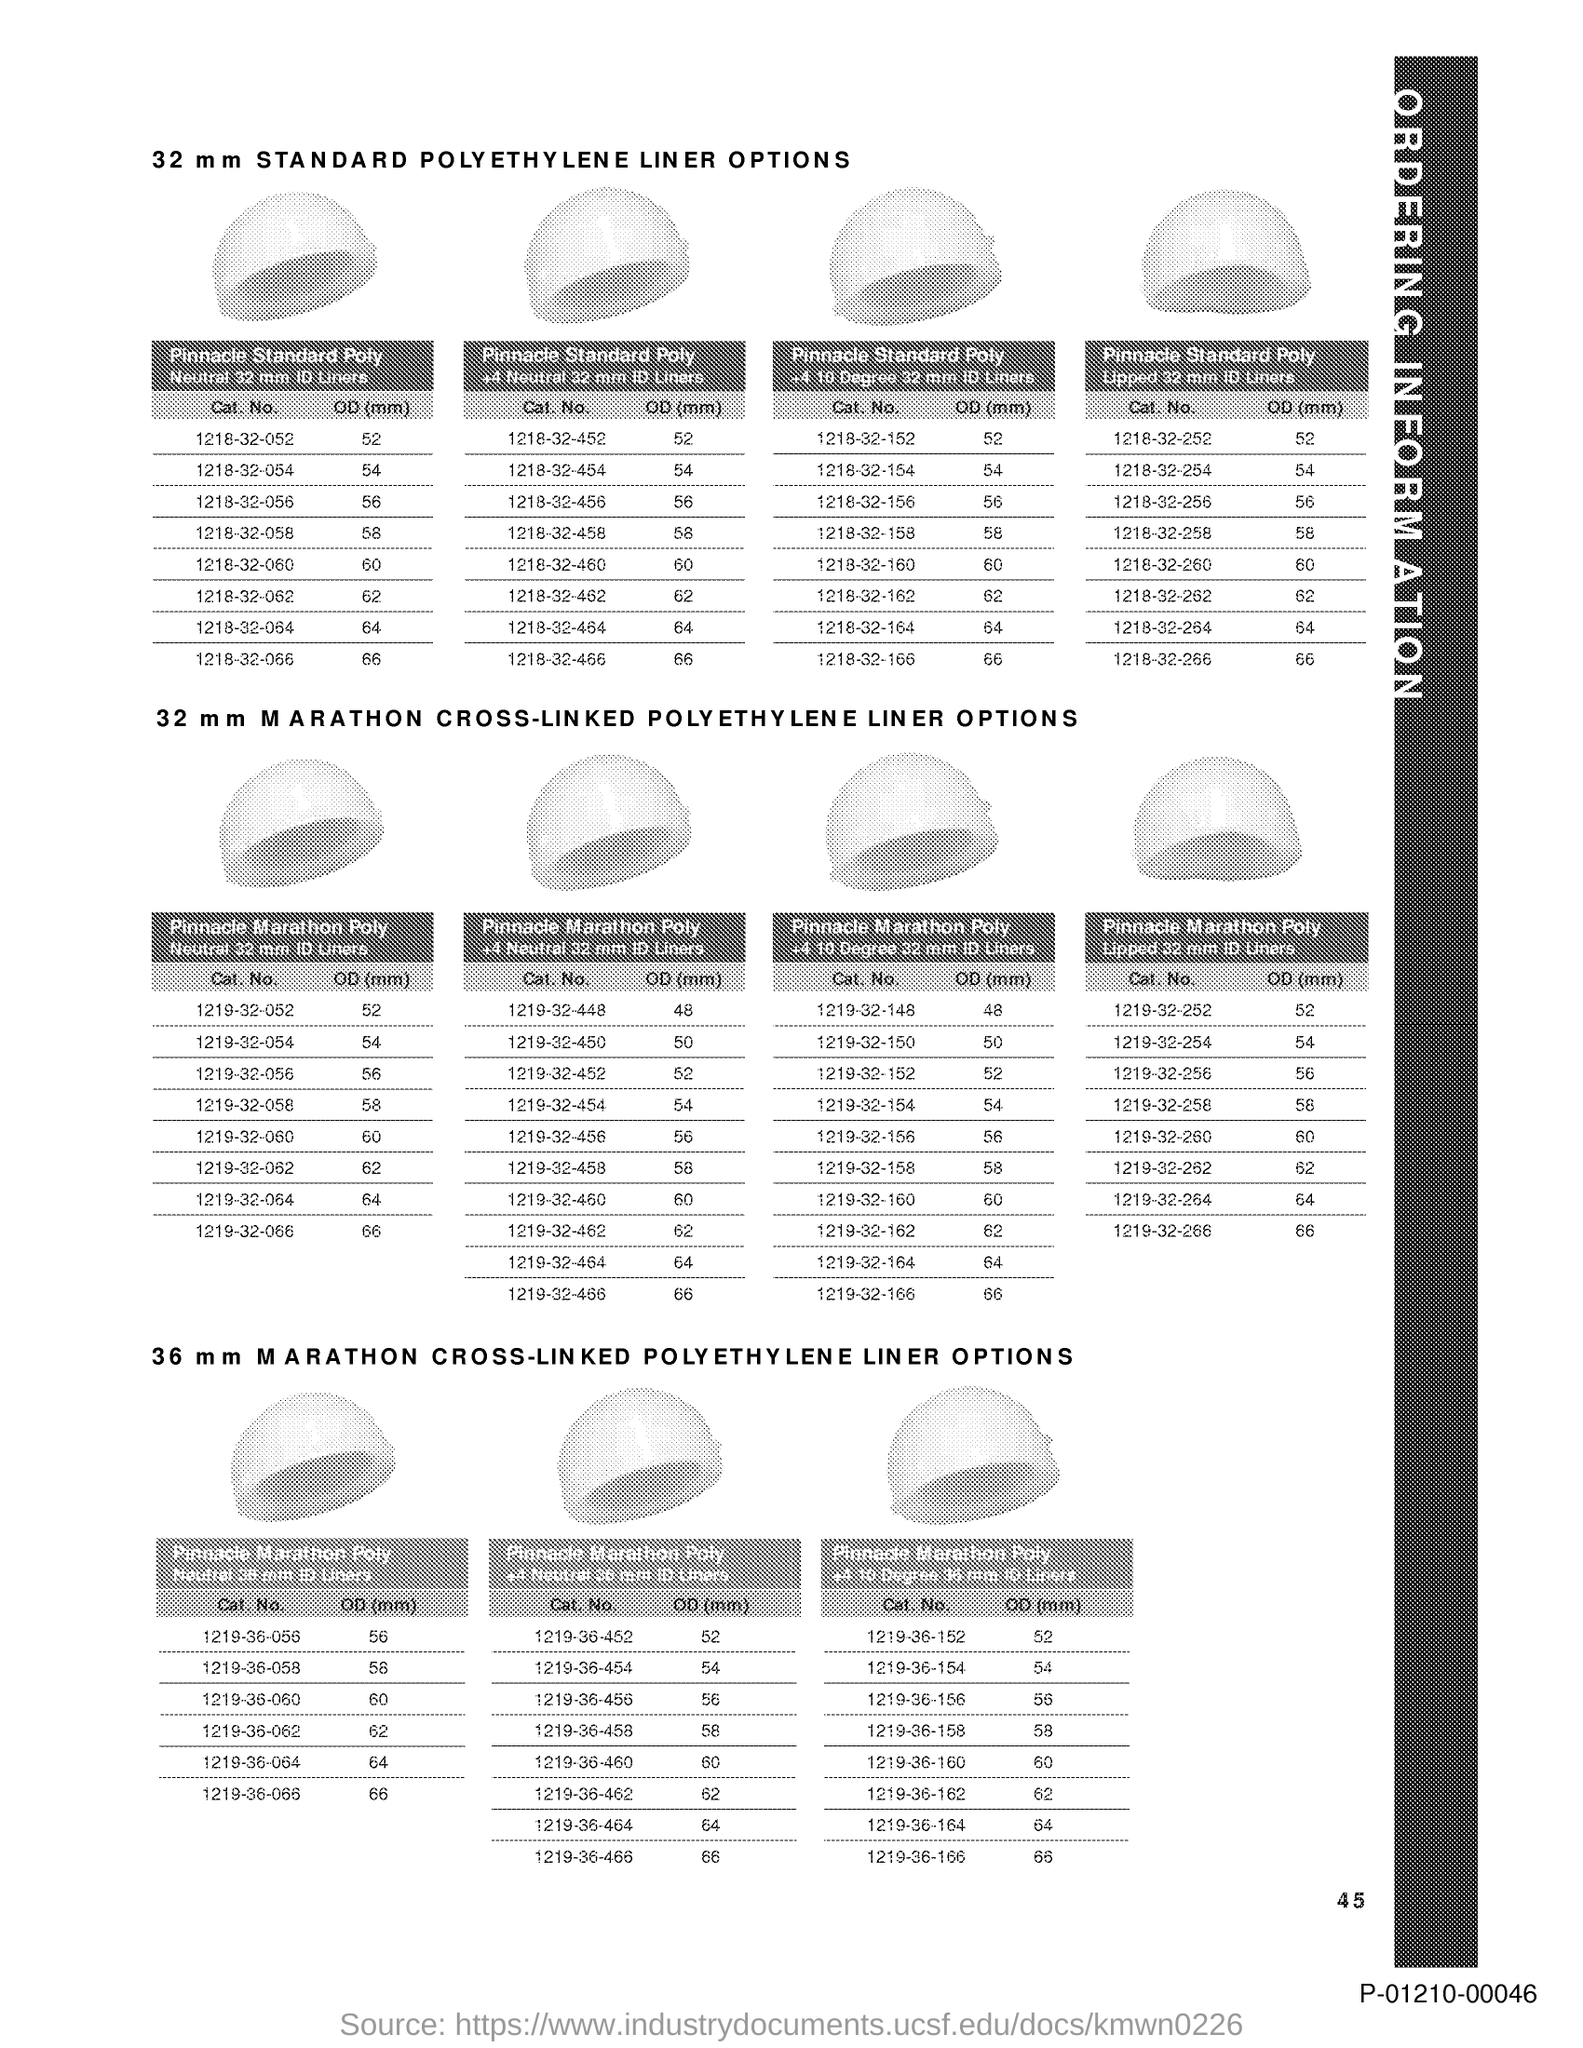Outline some significant characteristics in this image. The page number is 45. 